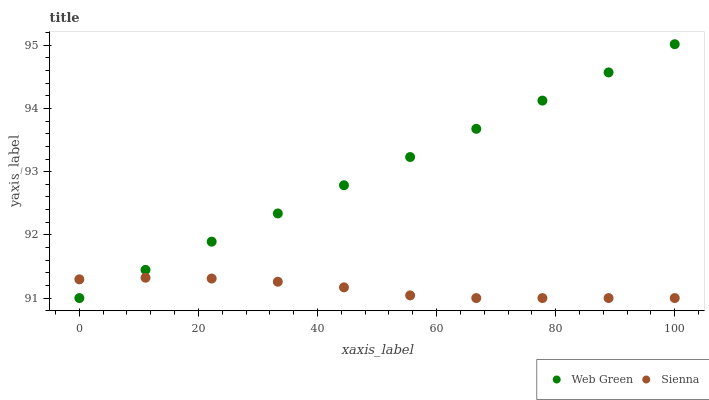Does Sienna have the minimum area under the curve?
Answer yes or no. Yes. Does Web Green have the maximum area under the curve?
Answer yes or no. Yes. Does Web Green have the minimum area under the curve?
Answer yes or no. No. Is Web Green the smoothest?
Answer yes or no. Yes. Is Sienna the roughest?
Answer yes or no. Yes. Is Web Green the roughest?
Answer yes or no. No. Does Sienna have the lowest value?
Answer yes or no. Yes. Does Web Green have the highest value?
Answer yes or no. Yes. Does Web Green intersect Sienna?
Answer yes or no. Yes. Is Web Green less than Sienna?
Answer yes or no. No. Is Web Green greater than Sienna?
Answer yes or no. No. 